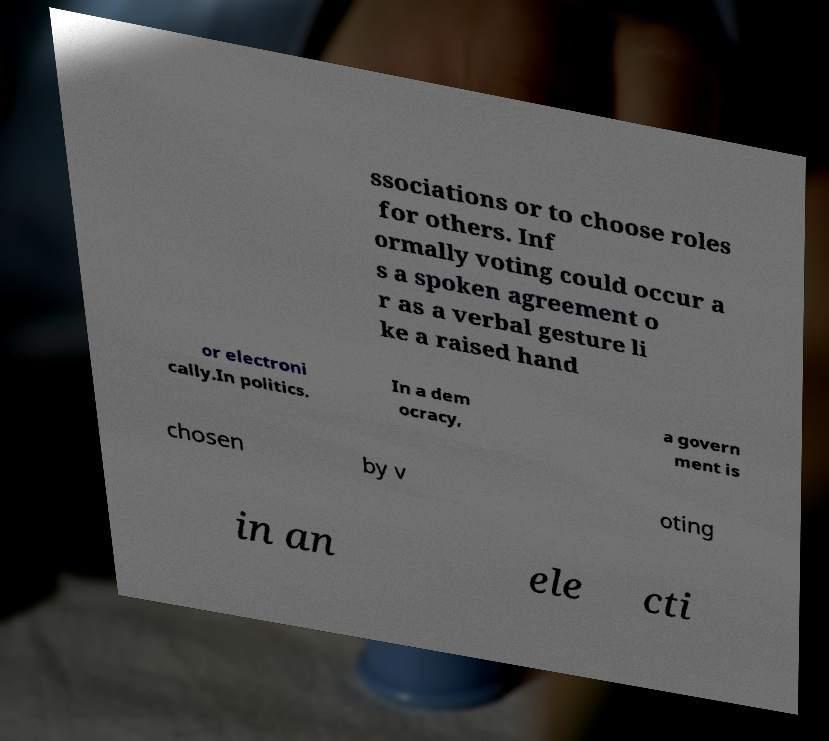For documentation purposes, I need the text within this image transcribed. Could you provide that? ssociations or to choose roles for others. Inf ormally voting could occur a s a spoken agreement o r as a verbal gesture li ke a raised hand or electroni cally.In politics. In a dem ocracy, a govern ment is chosen by v oting in an ele cti 